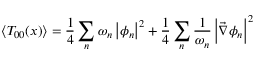Convert formula to latex. <formula><loc_0><loc_0><loc_500><loc_500>\left \langle T _ { 0 0 } ( x ) \right \rangle = \frac { 1 } { 4 } \sum _ { n } \omega _ { n } \left | \phi _ { n } \right | ^ { 2 } + \frac { 1 } { 4 } \sum _ { n } \frac { 1 } { \omega _ { n } } \left | \vec { \nabla } \phi _ { n } \right | ^ { 2 }</formula> 